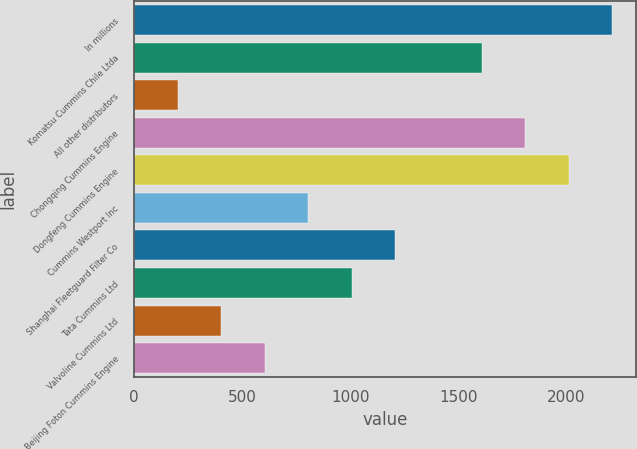<chart> <loc_0><loc_0><loc_500><loc_500><bar_chart><fcel>In millions<fcel>Komatsu Cummins Chile Ltda<fcel>All other distributors<fcel>Chongqing Cummins Engine<fcel>Dongfeng Cummins Engine<fcel>Cummins Westport Inc<fcel>Shanghai Fleetguard Filter Co<fcel>Tata Cummins Ltd<fcel>Valvoline Cummins Ltd<fcel>Beijing Foton Cummins Engine<nl><fcel>2211.8<fcel>1609.4<fcel>203.8<fcel>1810.2<fcel>2011<fcel>806.2<fcel>1207.8<fcel>1007<fcel>404.6<fcel>605.4<nl></chart> 